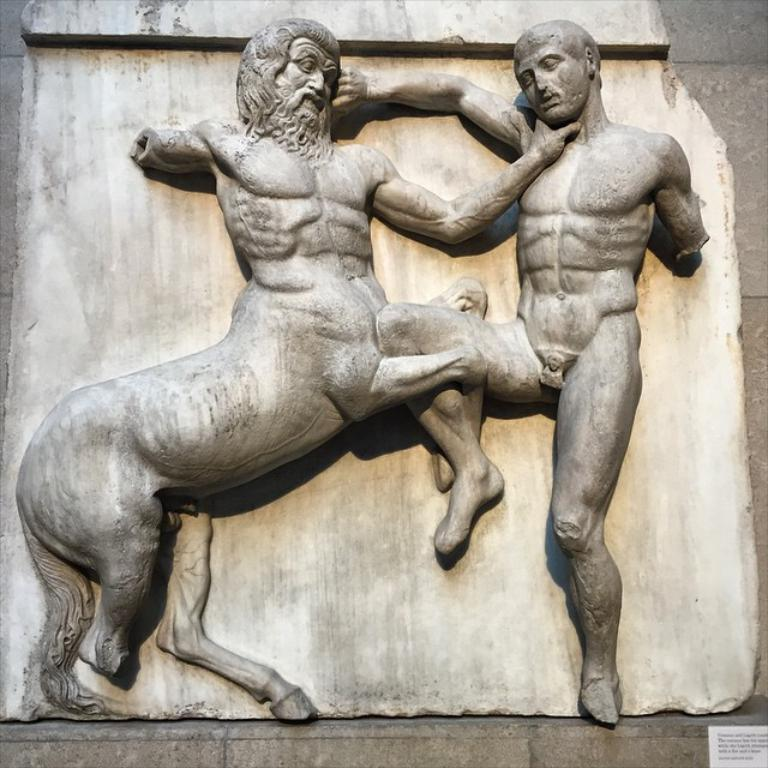What can be seen in the image? There are two sculptures in the image. Where are the sculptures located? The sculptures are on the wall. What type of love song is the band playing in the image? There is no band or love song present in the image; it features two sculptures on the wall. What kind of bun is being used to hold the sculptures together? There is no bun present in the image, as the sculptures are on the wall and not held together by any visible bun. 